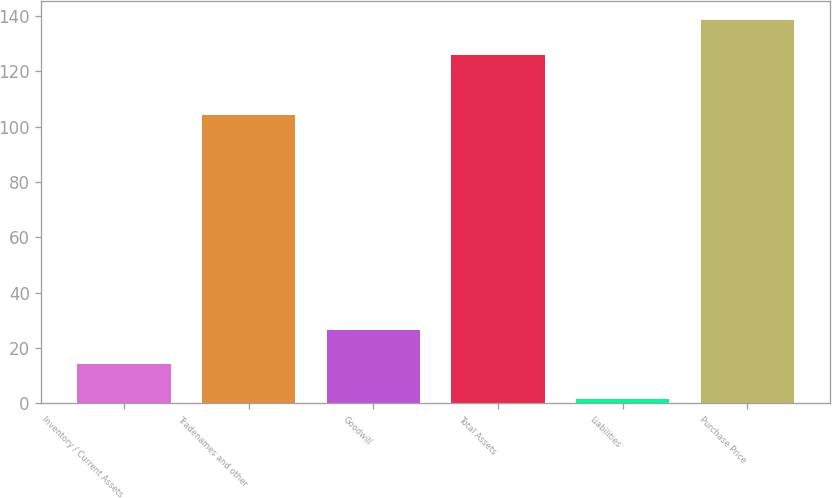Convert chart. <chart><loc_0><loc_0><loc_500><loc_500><bar_chart><fcel>Inventory / Current Assets<fcel>Tradenames and other<fcel>Goodwill<fcel>Total Assets<fcel>Liabilities<fcel>Purchase Price<nl><fcel>14.12<fcel>104.1<fcel>26.55<fcel>126<fcel>1.69<fcel>138.43<nl></chart> 